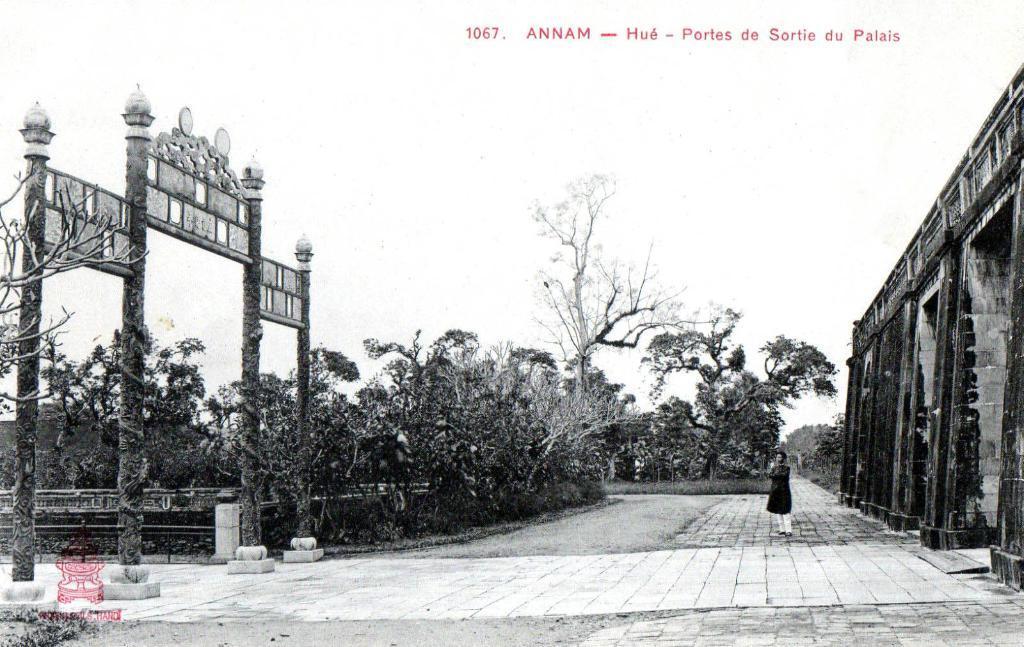Could you give a brief overview of what you see in this image? In this image we can see a black and white picture of a person standing on the ground. To the left side of the image we can see an arch with poles, group trees, fence and a logo with text. To the right side, we can see a building. In the background, we can see a group of trees, the sky and some text. 